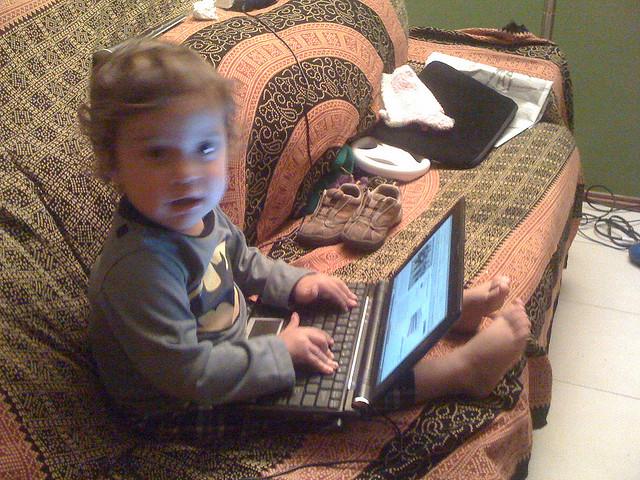Where is the shoes?
Be succinct. On couch. What is on the child's shirt?
Write a very short answer. Batman. What is this child playing with?
Keep it brief. Laptop. 